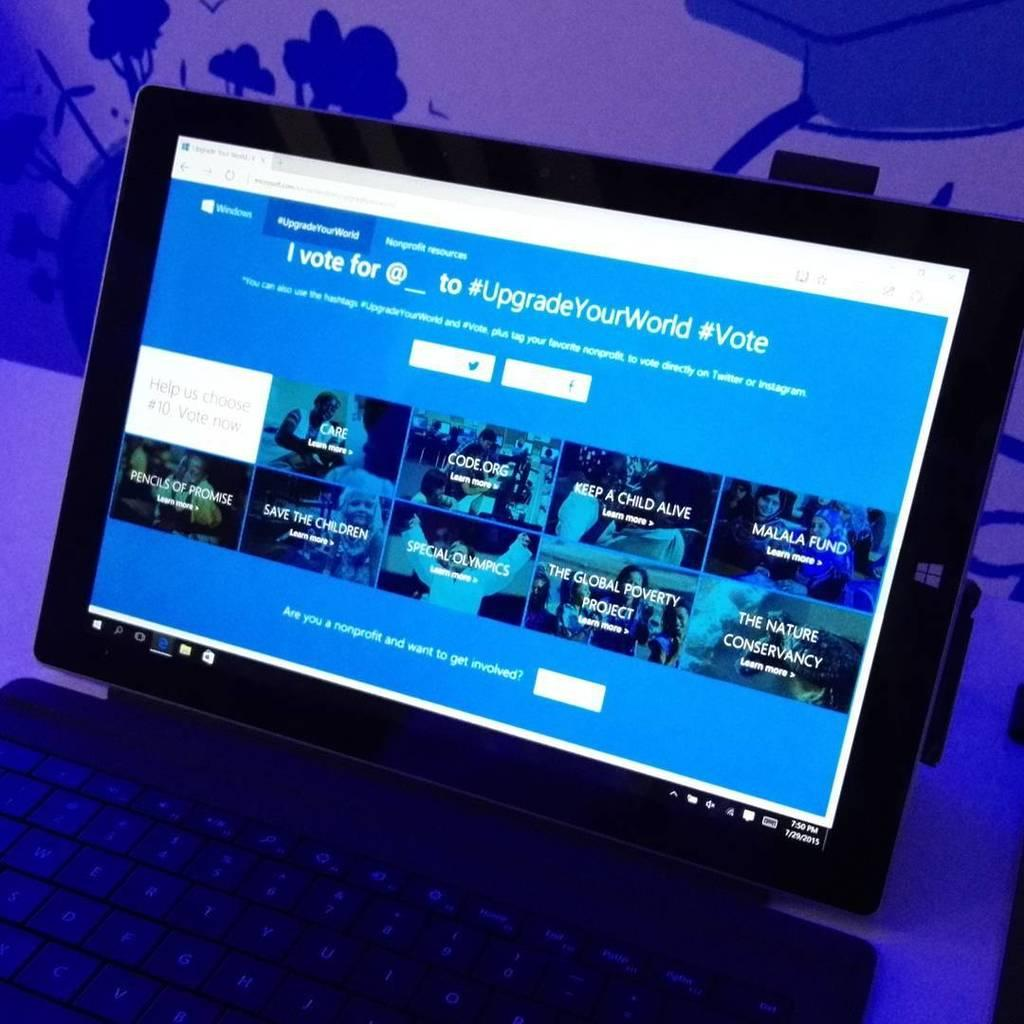<image>
Provide a brief description of the given image. laptop on 7/29/2015 at 7:50pm showing a windows page with sections for code.org, special olympics, and pencils of promise 